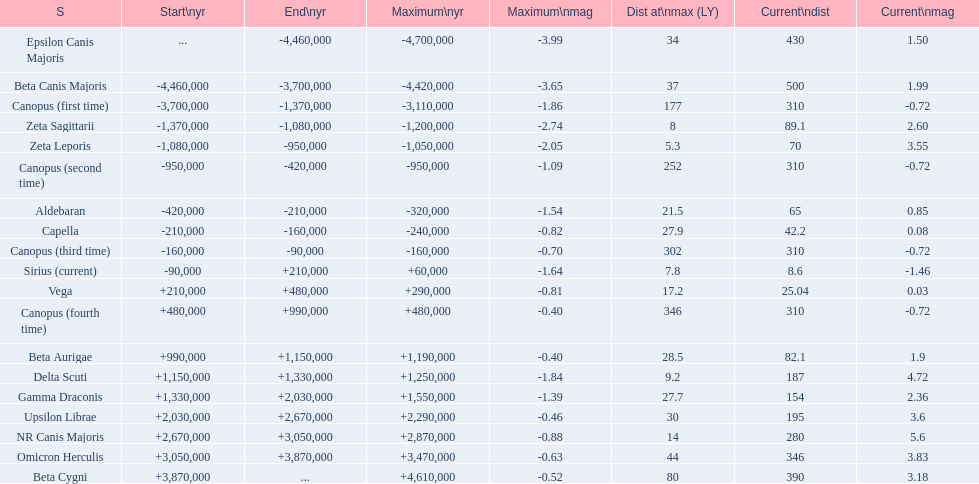How many stars have a magnitude greater than zero? 14. 